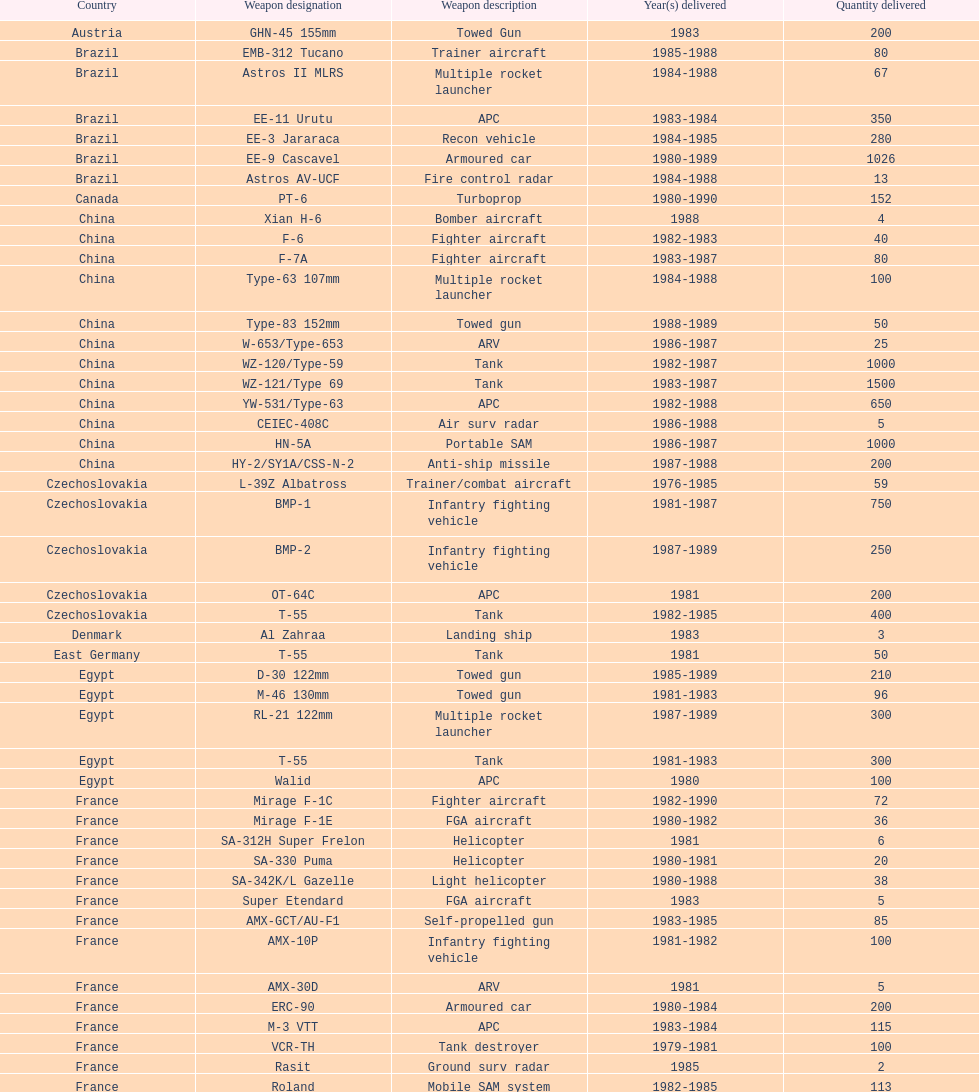Which country was the pioneer in selling weapons to iraq? Czechoslovakia. 